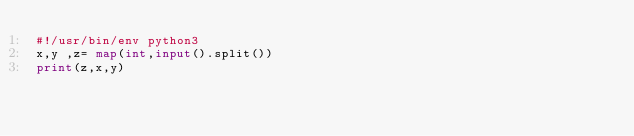<code> <loc_0><loc_0><loc_500><loc_500><_Python_>#!/usr/bin/env python3
x,y ,z= map(int,input().split())
print(z,x,y)</code> 